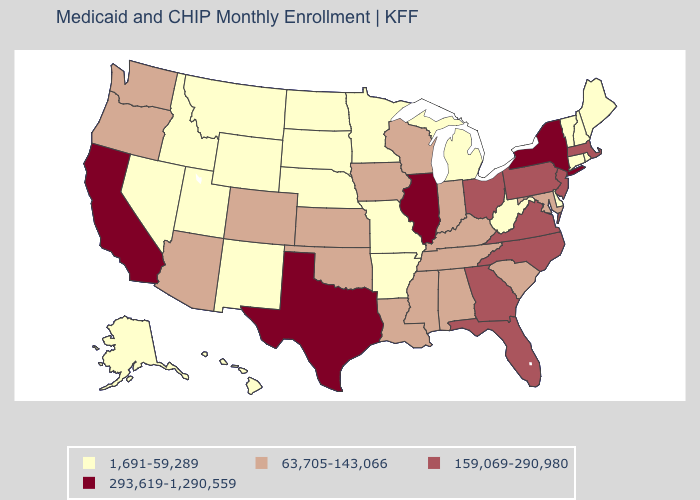Among the states that border Utah , which have the lowest value?
Answer briefly. Idaho, Nevada, New Mexico, Wyoming. Name the states that have a value in the range 1,691-59,289?
Be succinct. Alaska, Arkansas, Connecticut, Delaware, Hawaii, Idaho, Maine, Michigan, Minnesota, Missouri, Montana, Nebraska, Nevada, New Hampshire, New Mexico, North Dakota, Rhode Island, South Dakota, Utah, Vermont, West Virginia, Wyoming. What is the value of North Carolina?
Quick response, please. 159,069-290,980. Name the states that have a value in the range 159,069-290,980?
Keep it brief. Florida, Georgia, Massachusetts, New Jersey, North Carolina, Ohio, Pennsylvania, Virginia. What is the value of Ohio?
Keep it brief. 159,069-290,980. Does New Hampshire have the lowest value in the Northeast?
Quick response, please. Yes. How many symbols are there in the legend?
Concise answer only. 4. Name the states that have a value in the range 1,691-59,289?
Give a very brief answer. Alaska, Arkansas, Connecticut, Delaware, Hawaii, Idaho, Maine, Michigan, Minnesota, Missouri, Montana, Nebraska, Nevada, New Hampshire, New Mexico, North Dakota, Rhode Island, South Dakota, Utah, Vermont, West Virginia, Wyoming. Does Nebraska have the lowest value in the MidWest?
Keep it brief. Yes. What is the value of Missouri?
Quick response, please. 1,691-59,289. Among the states that border Maryland , does Delaware have the lowest value?
Be succinct. Yes. What is the highest value in states that border Delaware?
Concise answer only. 159,069-290,980. Name the states that have a value in the range 63,705-143,066?
Short answer required. Alabama, Arizona, Colorado, Indiana, Iowa, Kansas, Kentucky, Louisiana, Maryland, Mississippi, Oklahoma, Oregon, South Carolina, Tennessee, Washington, Wisconsin. 